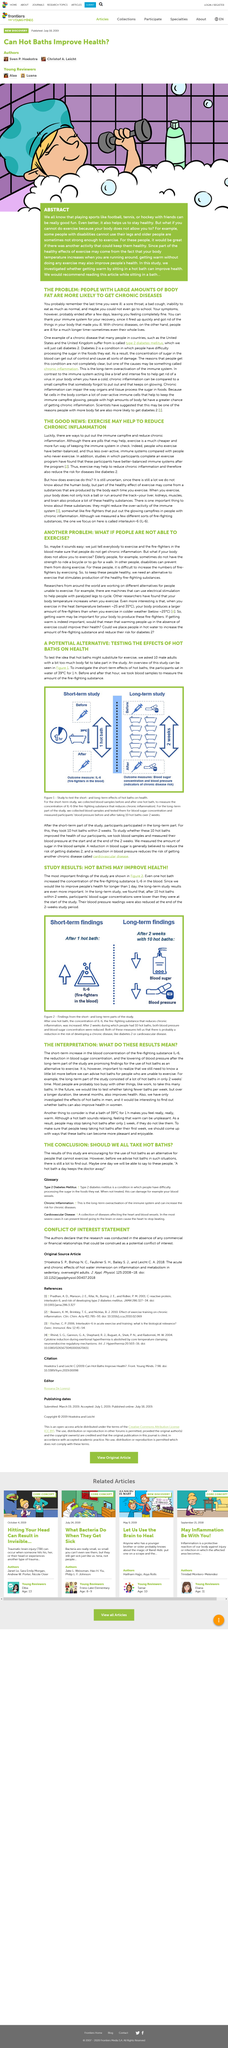Draw attention to some important aspects in this diagram. Chronic inflammation is a potential cause of type 2 diabetes. In the long-term part of the study, participants took 10 hot baths over a period of two weeks to assess the effects on their health. Type 2 diabetes is one example of a chronic disease. The study results demonstrate that hot baths may enhance health. The study collected blood samples before and after a single hot bath, for a short-term analysis. 